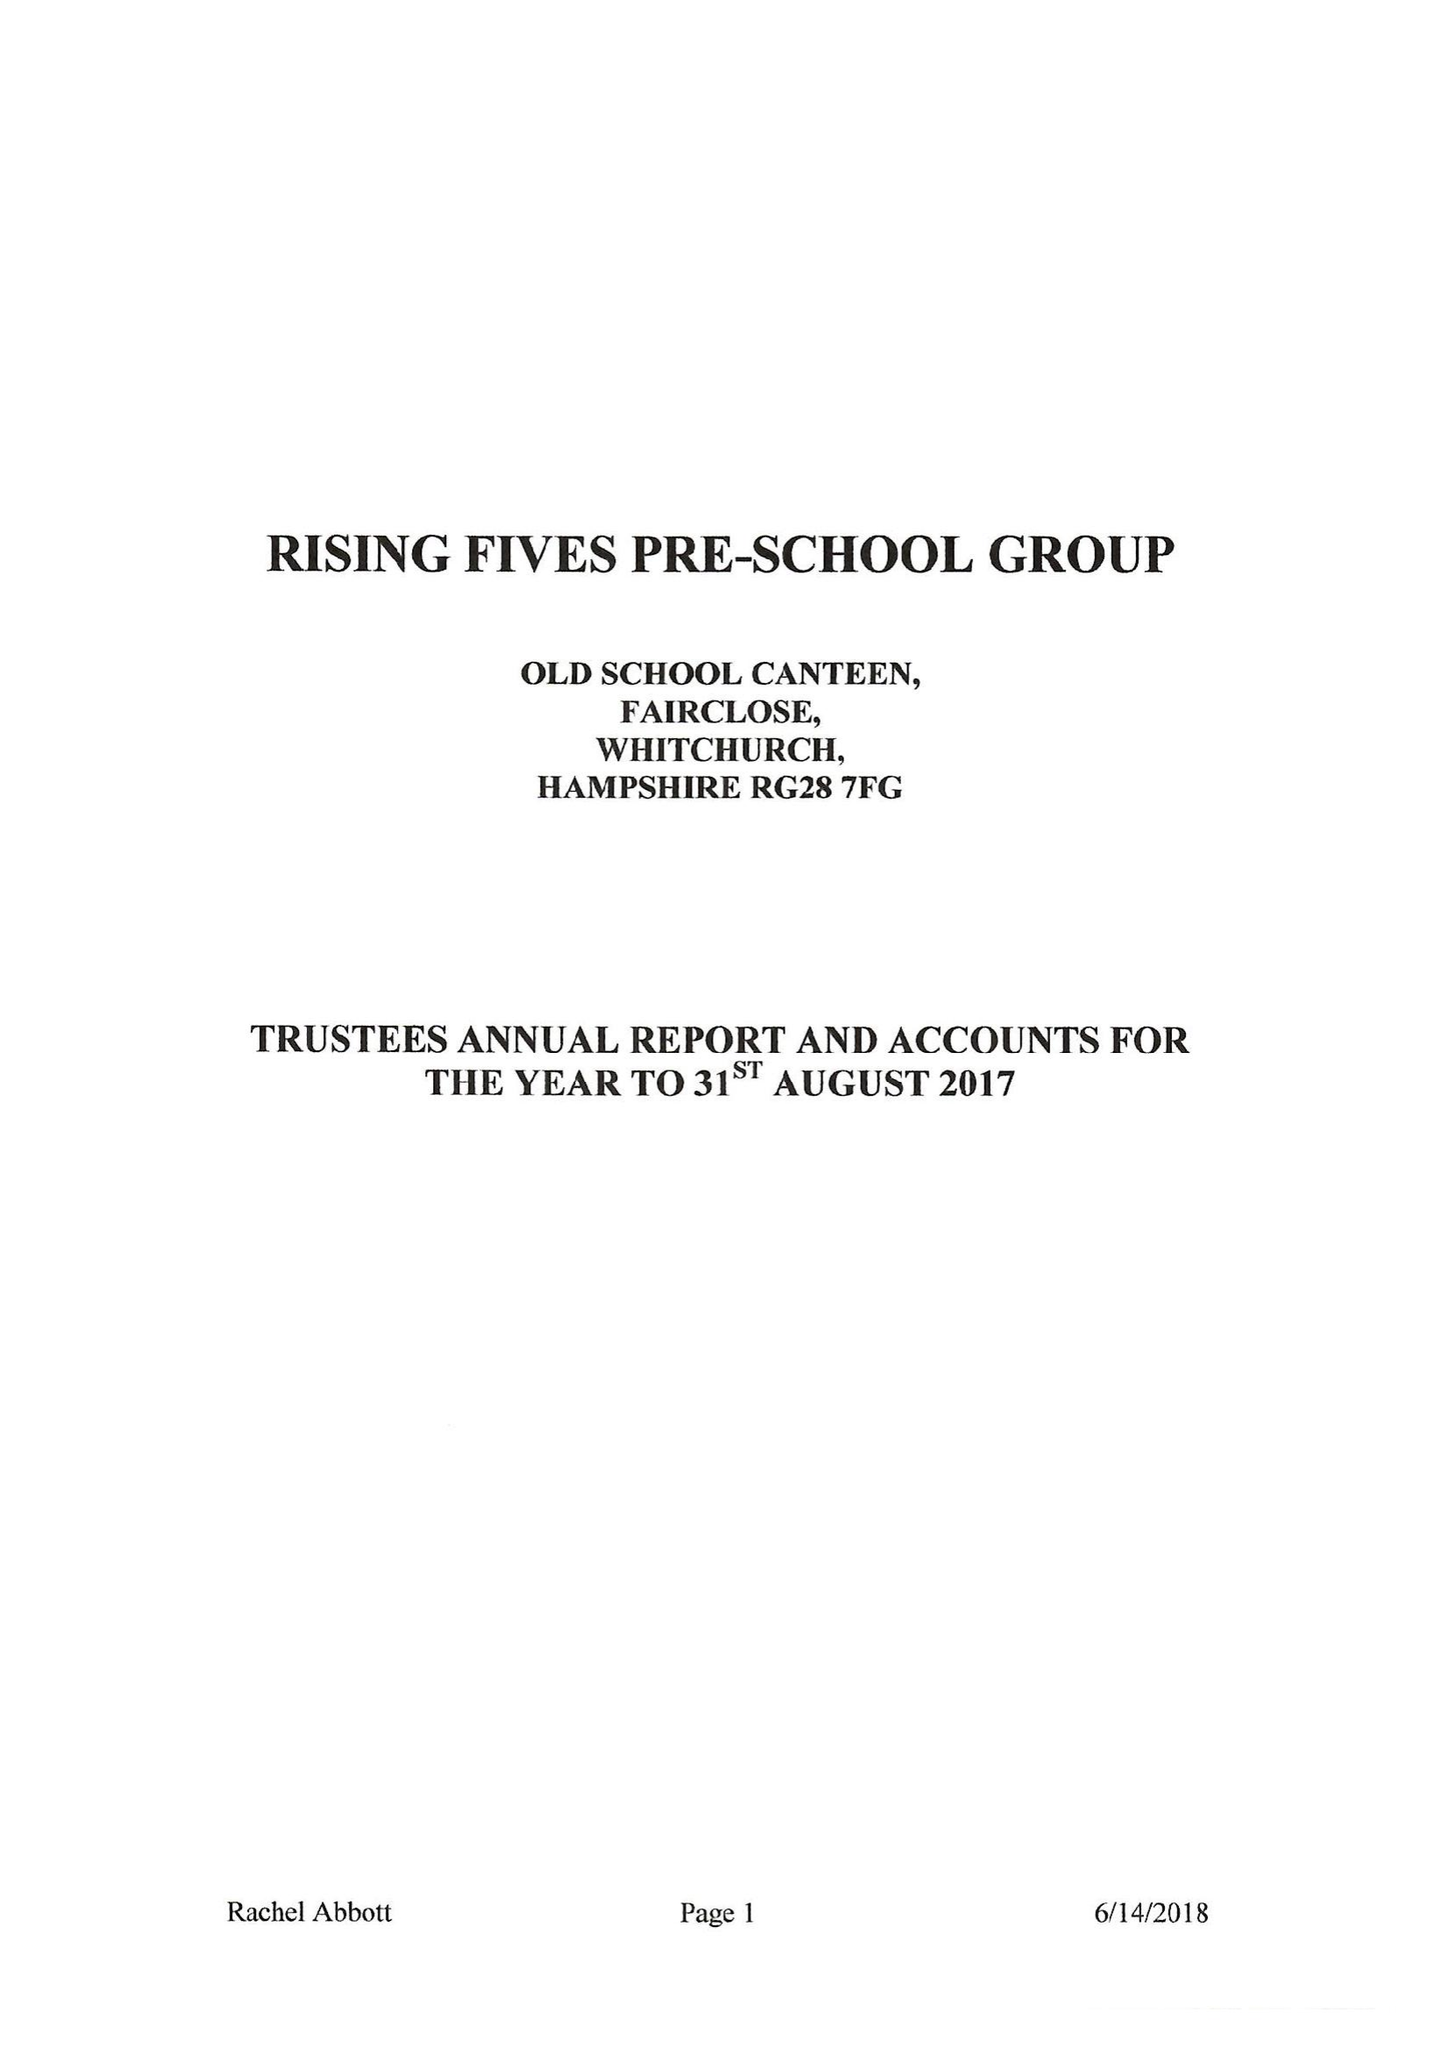What is the value for the address__postcode?
Answer the question using a single word or phrase. RG28 7AN 